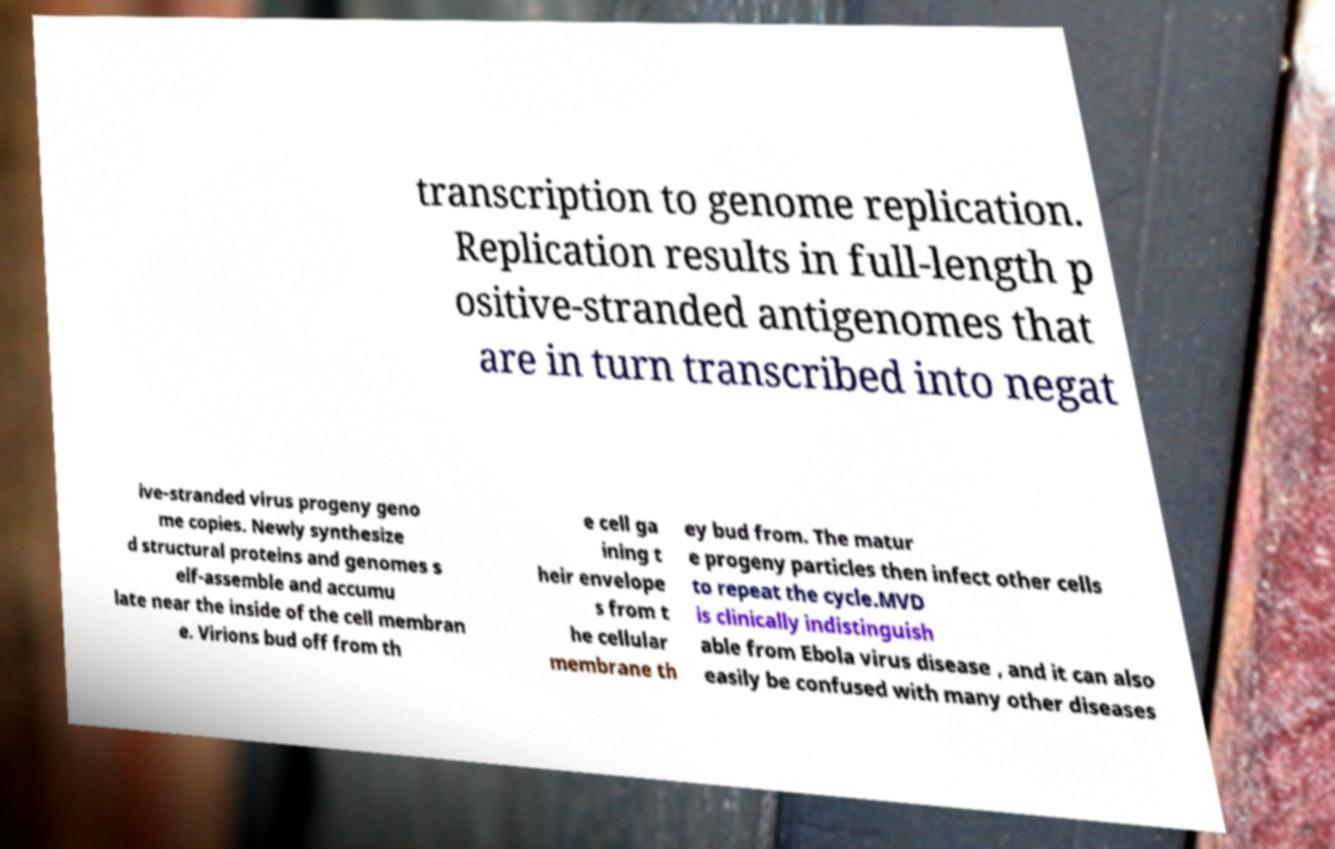There's text embedded in this image that I need extracted. Can you transcribe it verbatim? transcription to genome replication. Replication results in full-length p ositive-stranded antigenomes that are in turn transcribed into negat ive-stranded virus progeny geno me copies. Newly synthesize d structural proteins and genomes s elf-assemble and accumu late near the inside of the cell membran e. Virions bud off from th e cell ga ining t heir envelope s from t he cellular membrane th ey bud from. The matur e progeny particles then infect other cells to repeat the cycle.MVD is clinically indistinguish able from Ebola virus disease , and it can also easily be confused with many other diseases 